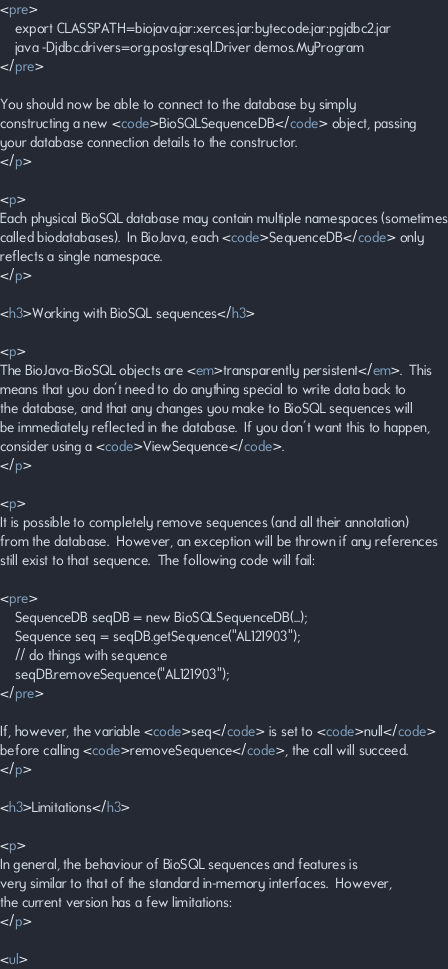<code> <loc_0><loc_0><loc_500><loc_500><_HTML_><pre>
    export CLASSPATH=biojava.jar:xerces.jar:bytecode.jar:pgjdbc2.jar
    java -Djdbc.drivers=org.postgresql.Driver demos.MyProgram
</pre>

You should now be able to connect to the database by simply
constructing a new <code>BioSQLSequenceDB</code> object, passing
your database connection details to the constructor.
</p>

<p>
Each physical BioSQL database may contain multiple namespaces (sometimes
called biodatabases).  In BioJava, each <code>SequenceDB</code> only
reflects a single namespace.
</p>

<h3>Working with BioSQL sequences</h3>

<p>
The BioJava-BioSQL objects are <em>transparently persistent</em>.  This
means that you don't need to do anything special to write data back to
the database, and that any changes you make to BioSQL sequences will
be immediately reflected in the database.  If you don't want this to happen,
consider using a <code>ViewSequence</code>.
</p>

<p>
It is possible to completely remove sequences (and all their annotation)
from the database.  However, an exception will be thrown if any references
still exist to that sequence.  The following code will fail:

<pre>
    SequenceDB seqDB = new BioSQLSequenceDB(...);
    Sequence seq = seqDB.getSequence("AL121903");
    // do things with sequence
    seqDB.removeSequence("AL121903");
</pre>

If, however, the variable <code>seq</code> is set to <code>null</code>
before calling <code>removeSequence</code>, the call will succeed.
</p>

<h3>Limitations</h3>

<p>
In general, the behaviour of BioSQL sequences and features is
very similar to that of the standard in-memory interfaces.  However,
the current version has a few limitations:
</p>

<ul></code> 